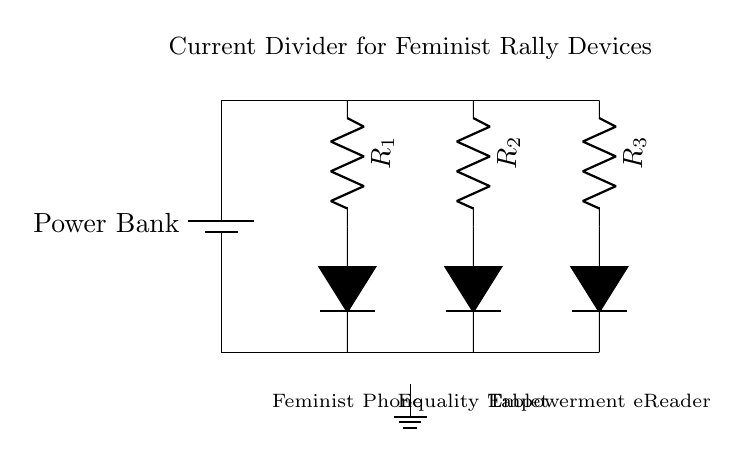What is the main component providing power in this circuit? The main component providing power in this circuit is the battery, labeled as Power Bank, which is located at the top.
Answer: Power Bank How many resistors are present in the circuit? There are three resistors connected in series to create a current divider for distributing power among multiple devices. The resistors are labeled R1, R2, and R3.
Answer: Three What type of devices does this circuit support? The circuit supports three types of devices: a Feminist Phone, an Equality Tablet, and an Empowerment eReader, as indicated by their labels below the devices.
Answer: Feminist Phone, Equality Tablet, Empowerment eReader Which resistor is closest to the battery? The resistor closest to the battery is R1, which is the first resistor connected below the Power Bank.
Answer: R1 What purpose does the current divider serve in this circuit? The current divider serves to distribute the available current from the Power Bank into multiple branches, allowing simultaneous charging of devices without overloading any individual component.
Answer: Distribute current If all resistors are equal, how would the current be divided among the devices? If all resistors are equal, the current would be divided equally among the three devices, as per the current divider rule, which states equal resistances split the total current proportionally.
Answer: Equally 